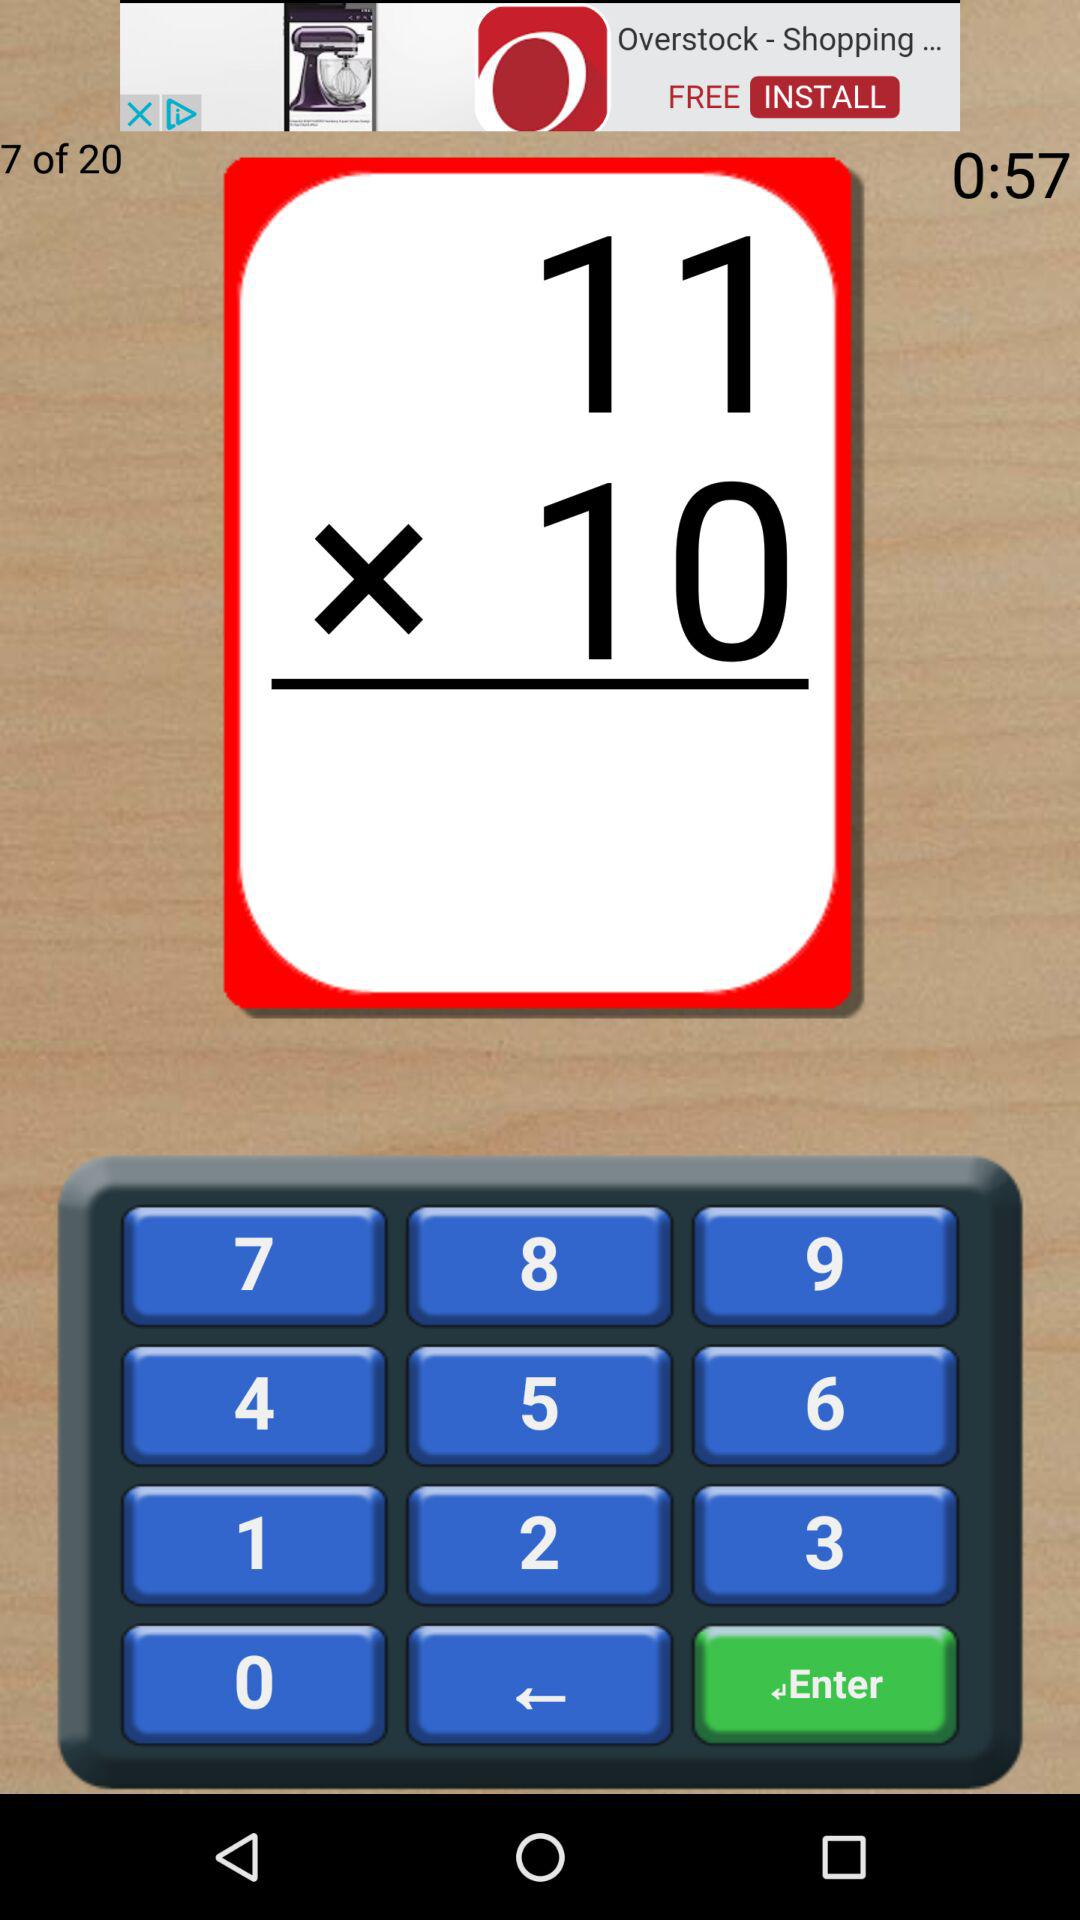What is the total number of questions? The total number of questions is 20. 